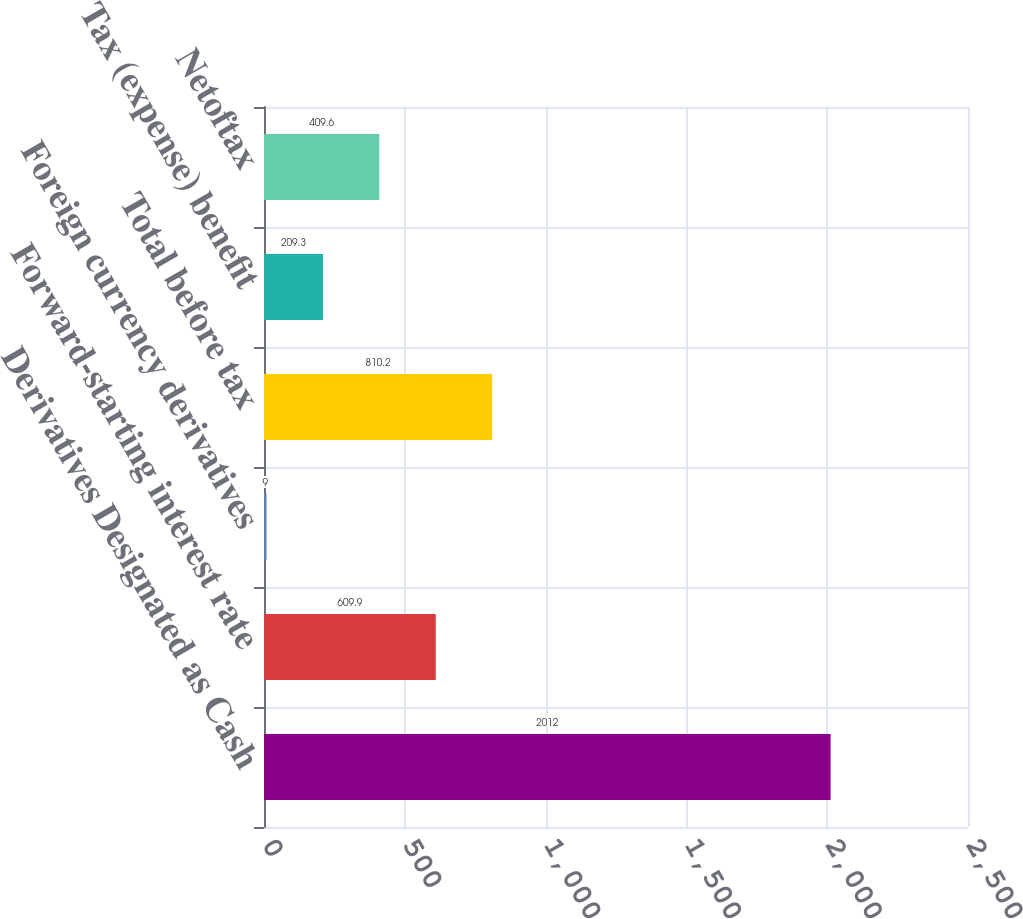Convert chart to OTSL. <chart><loc_0><loc_0><loc_500><loc_500><bar_chart><fcel>Derivatives Designated as Cash<fcel>Forward-starting interest rate<fcel>Foreign currency derivatives<fcel>Total before tax<fcel>Tax (expense) benefit<fcel>Netoftax<nl><fcel>2012<fcel>609.9<fcel>9<fcel>810.2<fcel>209.3<fcel>409.6<nl></chart> 